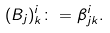<formula> <loc_0><loc_0><loc_500><loc_500>( B _ { j } ) ^ { i } _ { k } \colon = \beta ^ { i } _ { j k } .</formula> 